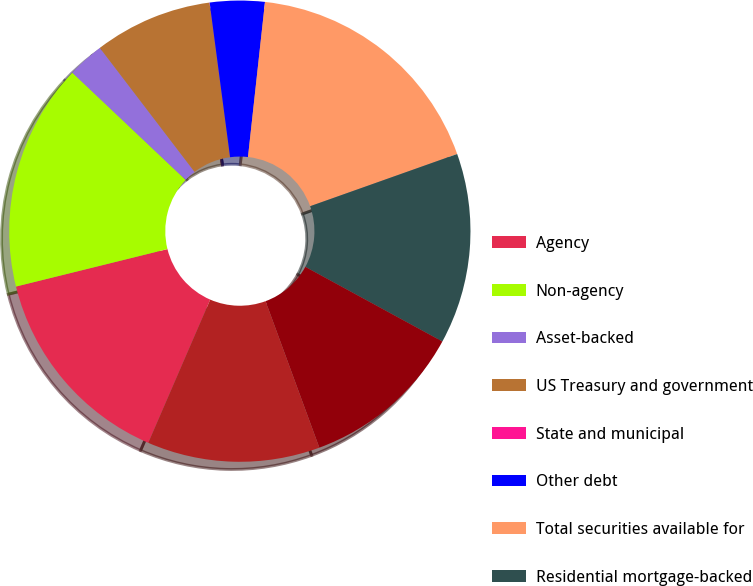<chart> <loc_0><loc_0><loc_500><loc_500><pie_chart><fcel>Agency<fcel>Non-agency<fcel>Asset-backed<fcel>US Treasury and government<fcel>State and municipal<fcel>Other debt<fcel>Total securities available for<fcel>Residential mortgage-backed<fcel>Commercial mortgage-backed<fcel>Total securities held to<nl><fcel>14.64%<fcel>15.92%<fcel>2.56%<fcel>8.28%<fcel>0.01%<fcel>3.83%<fcel>17.83%<fcel>13.37%<fcel>11.46%<fcel>12.1%<nl></chart> 